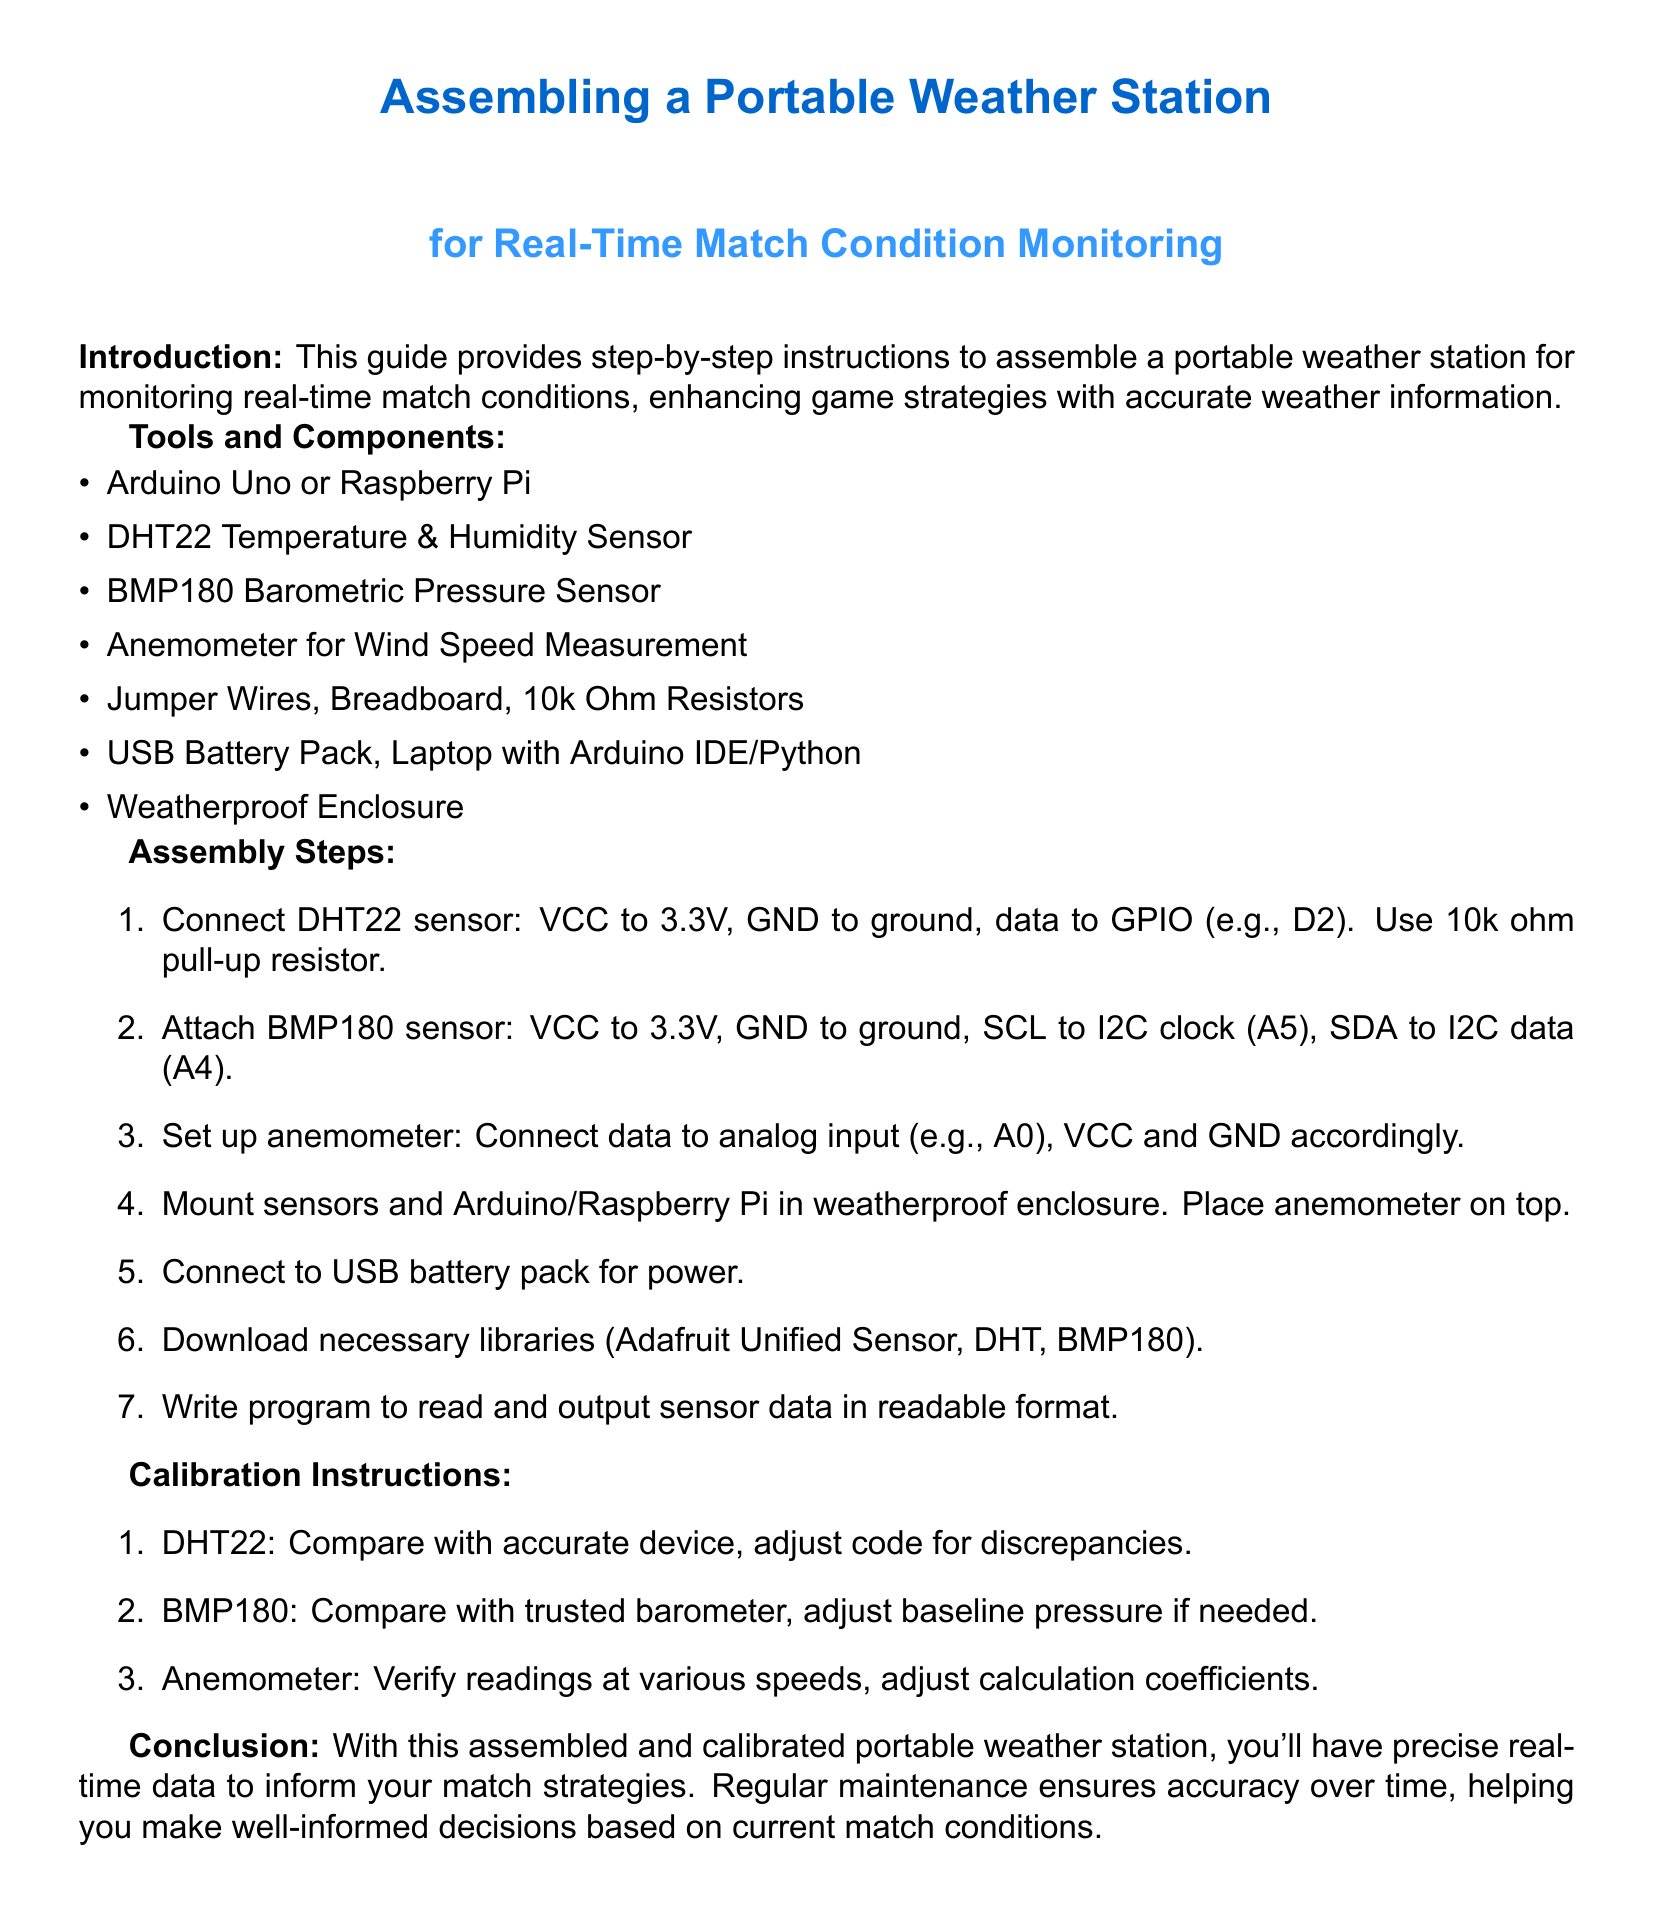What components are needed for assembly? The components listed in the document include Arduino Uno or Raspberry Pi, DHT22 sensor, BMP180 sensor, anemometer, jumper wires, breadboard, resistors, USB battery pack, laptop, and weatherproof enclosure.
Answer: Arduino Uno or Raspberry Pi, DHT22 sensor, BMP180 sensor, anemometer, jumper wires, breadboard, 10k Ohm resistors, USB battery pack, laptop, weatherproof enclosure What is the first step in the assembly process? The first step detailed in the document is to connect the DHT22 sensor to VCC, GND, and a GPIO pin using a pull-up resistor.
Answer: Connect DHT22 sensor: VCC to 3.3V, GND to ground, data to GPIO (e.g., D2) How should the BMP180 sensor be connected? The BMP180 sensor's connections involve VCC to 3.3V, GND to ground, and its communication pins to I2C clock and data.
Answer: VCC to 3.3V, GND to ground, SCL to I2C clock (A5), SDA to I2C data (A4) What adjustment is needed for the DHT22 during calibration? During calibration, the DHT22 needs to be compared with an accurate device and adjustments made in the code for any discrepancies.
Answer: Compare with accurate device, adjust code for discrepancies What type of sensor is used for wind speed measurement? The document specifies that an anemometer is used for measuring wind speed.
Answer: Anemometer What is the purpose of the weatherproof enclosure? The weatherproof enclosure is meant to protect the assembled components from environmental elements while in use.
Answer: Protect the assembled components What libraries need to be downloaded? The libraries mentioned in the assembly instructions include Adafruit Unified Sensor, DHT, and BMP180.
Answer: Adafruit Unified Sensor, DHT, BMP180 What is the outcome of using the assembled weather station? The outcome of assembling the weather station is having precise real-time data for informing match strategies.
Answer: Precise real-time data to inform match strategies 